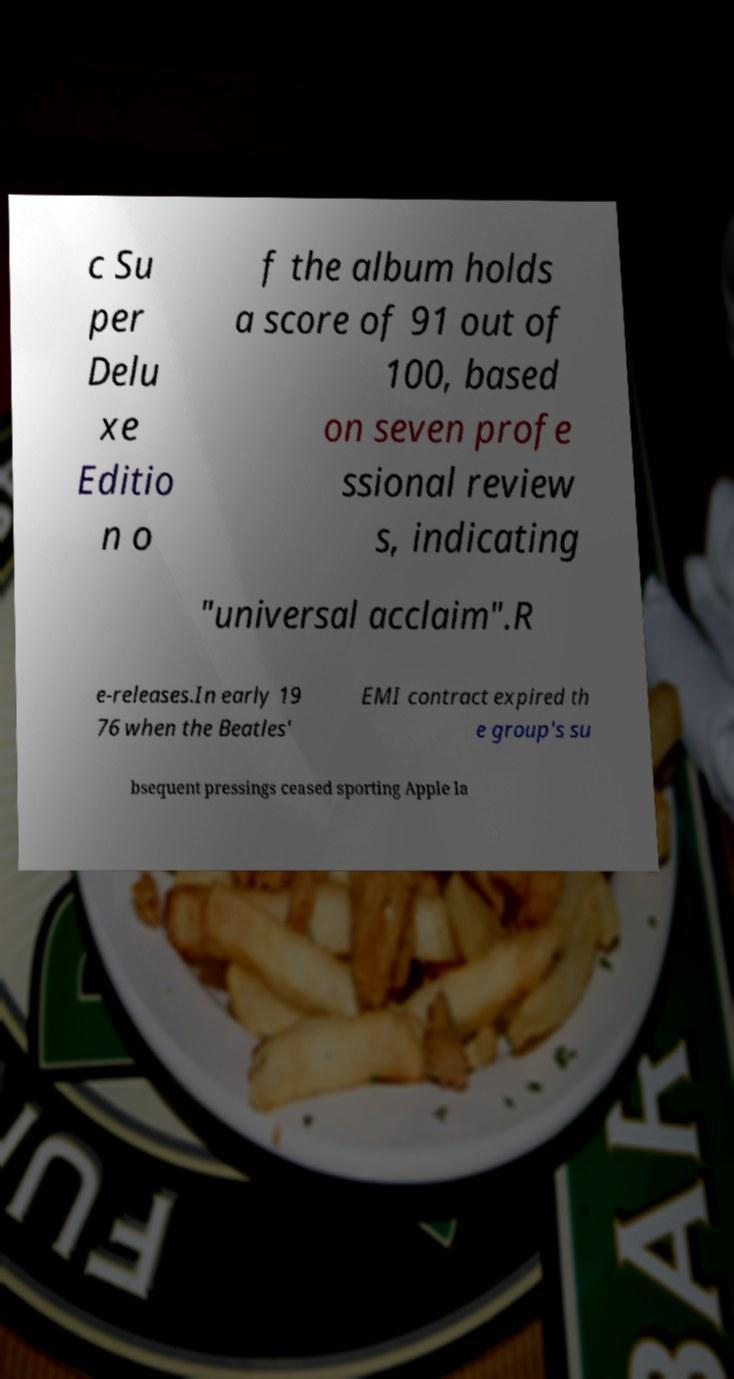I need the written content from this picture converted into text. Can you do that? c Su per Delu xe Editio n o f the album holds a score of 91 out of 100, based on seven profe ssional review s, indicating "universal acclaim".R e-releases.In early 19 76 when the Beatles' EMI contract expired th e group's su bsequent pressings ceased sporting Apple la 